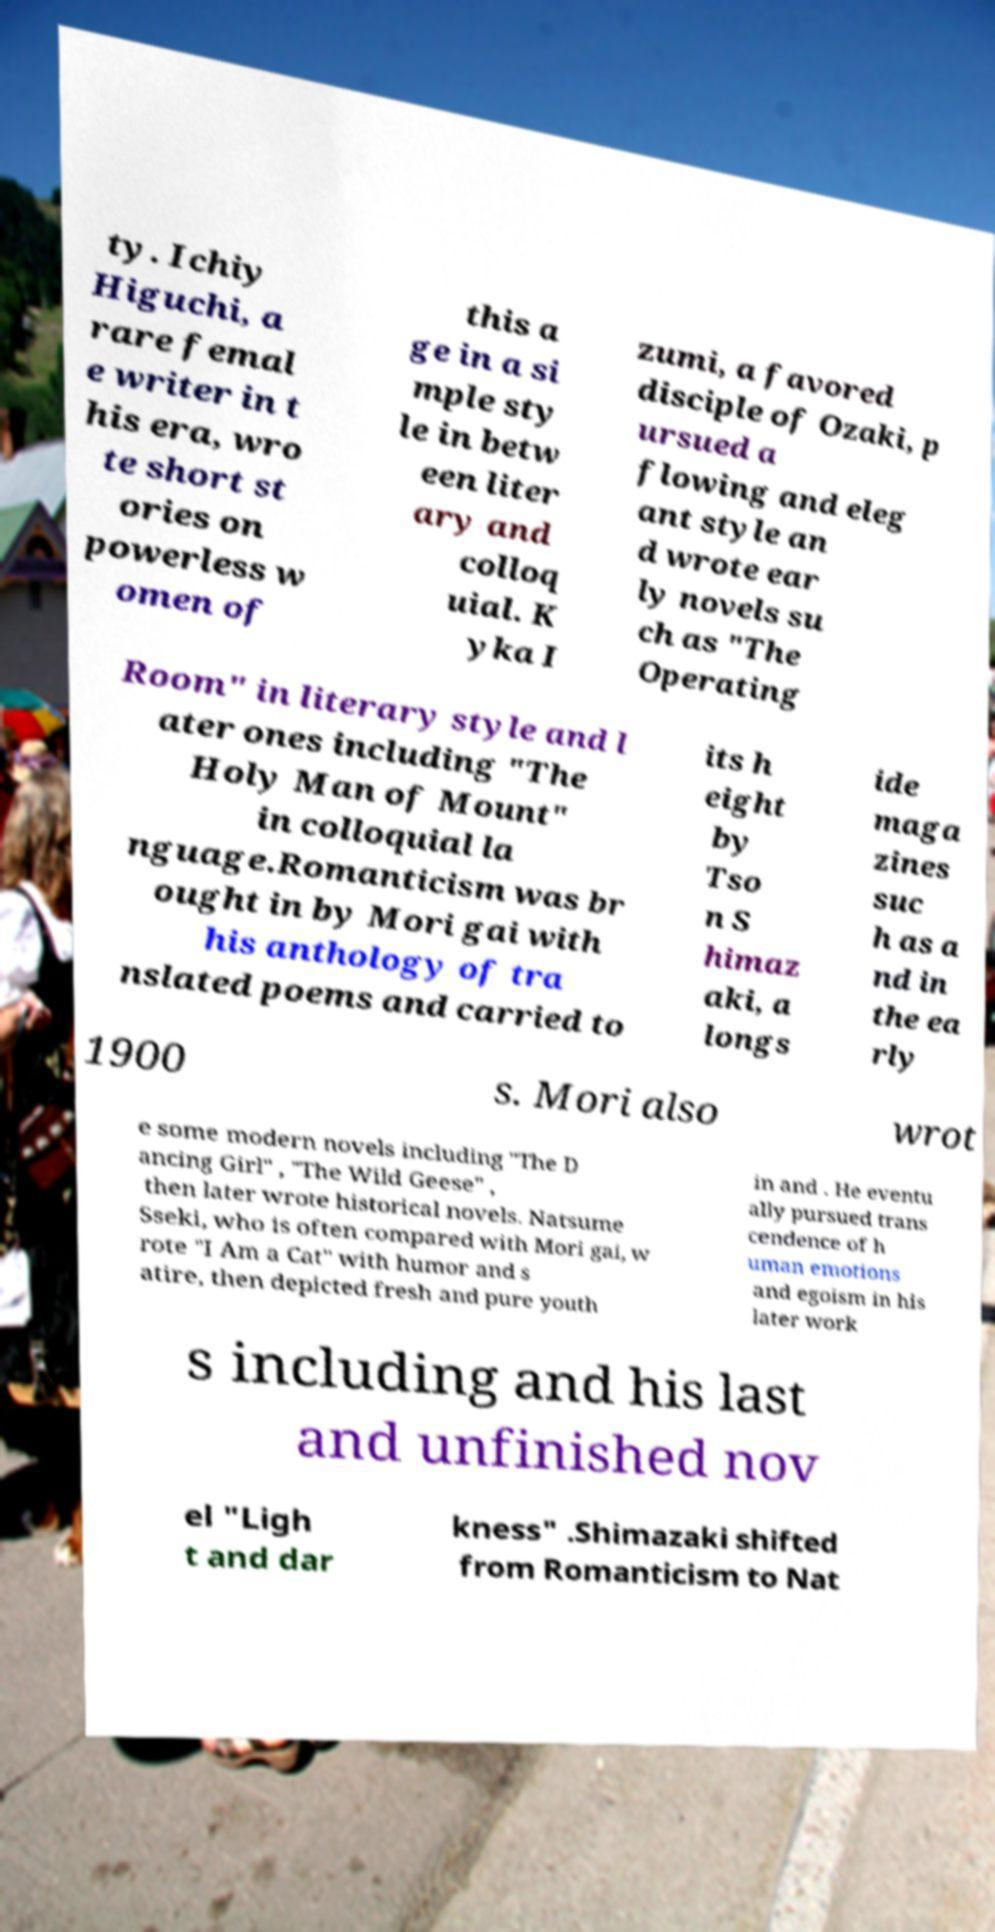I need the written content from this picture converted into text. Can you do that? ty. Ichiy Higuchi, a rare femal e writer in t his era, wro te short st ories on powerless w omen of this a ge in a si mple sty le in betw een liter ary and colloq uial. K yka I zumi, a favored disciple of Ozaki, p ursued a flowing and eleg ant style an d wrote ear ly novels su ch as "The Operating Room" in literary style and l ater ones including "The Holy Man of Mount" in colloquial la nguage.Romanticism was br ought in by Mori gai with his anthology of tra nslated poems and carried to its h eight by Tso n S himaz aki, a longs ide maga zines suc h as a nd in the ea rly 1900 s. Mori also wrot e some modern novels including "The D ancing Girl" , "The Wild Geese" , then later wrote historical novels. Natsume Sseki, who is often compared with Mori gai, w rote "I Am a Cat" with humor and s atire, then depicted fresh and pure youth in and . He eventu ally pursued trans cendence of h uman emotions and egoism in his later work s including and his last and unfinished nov el "Ligh t and dar kness" .Shimazaki shifted from Romanticism to Nat 